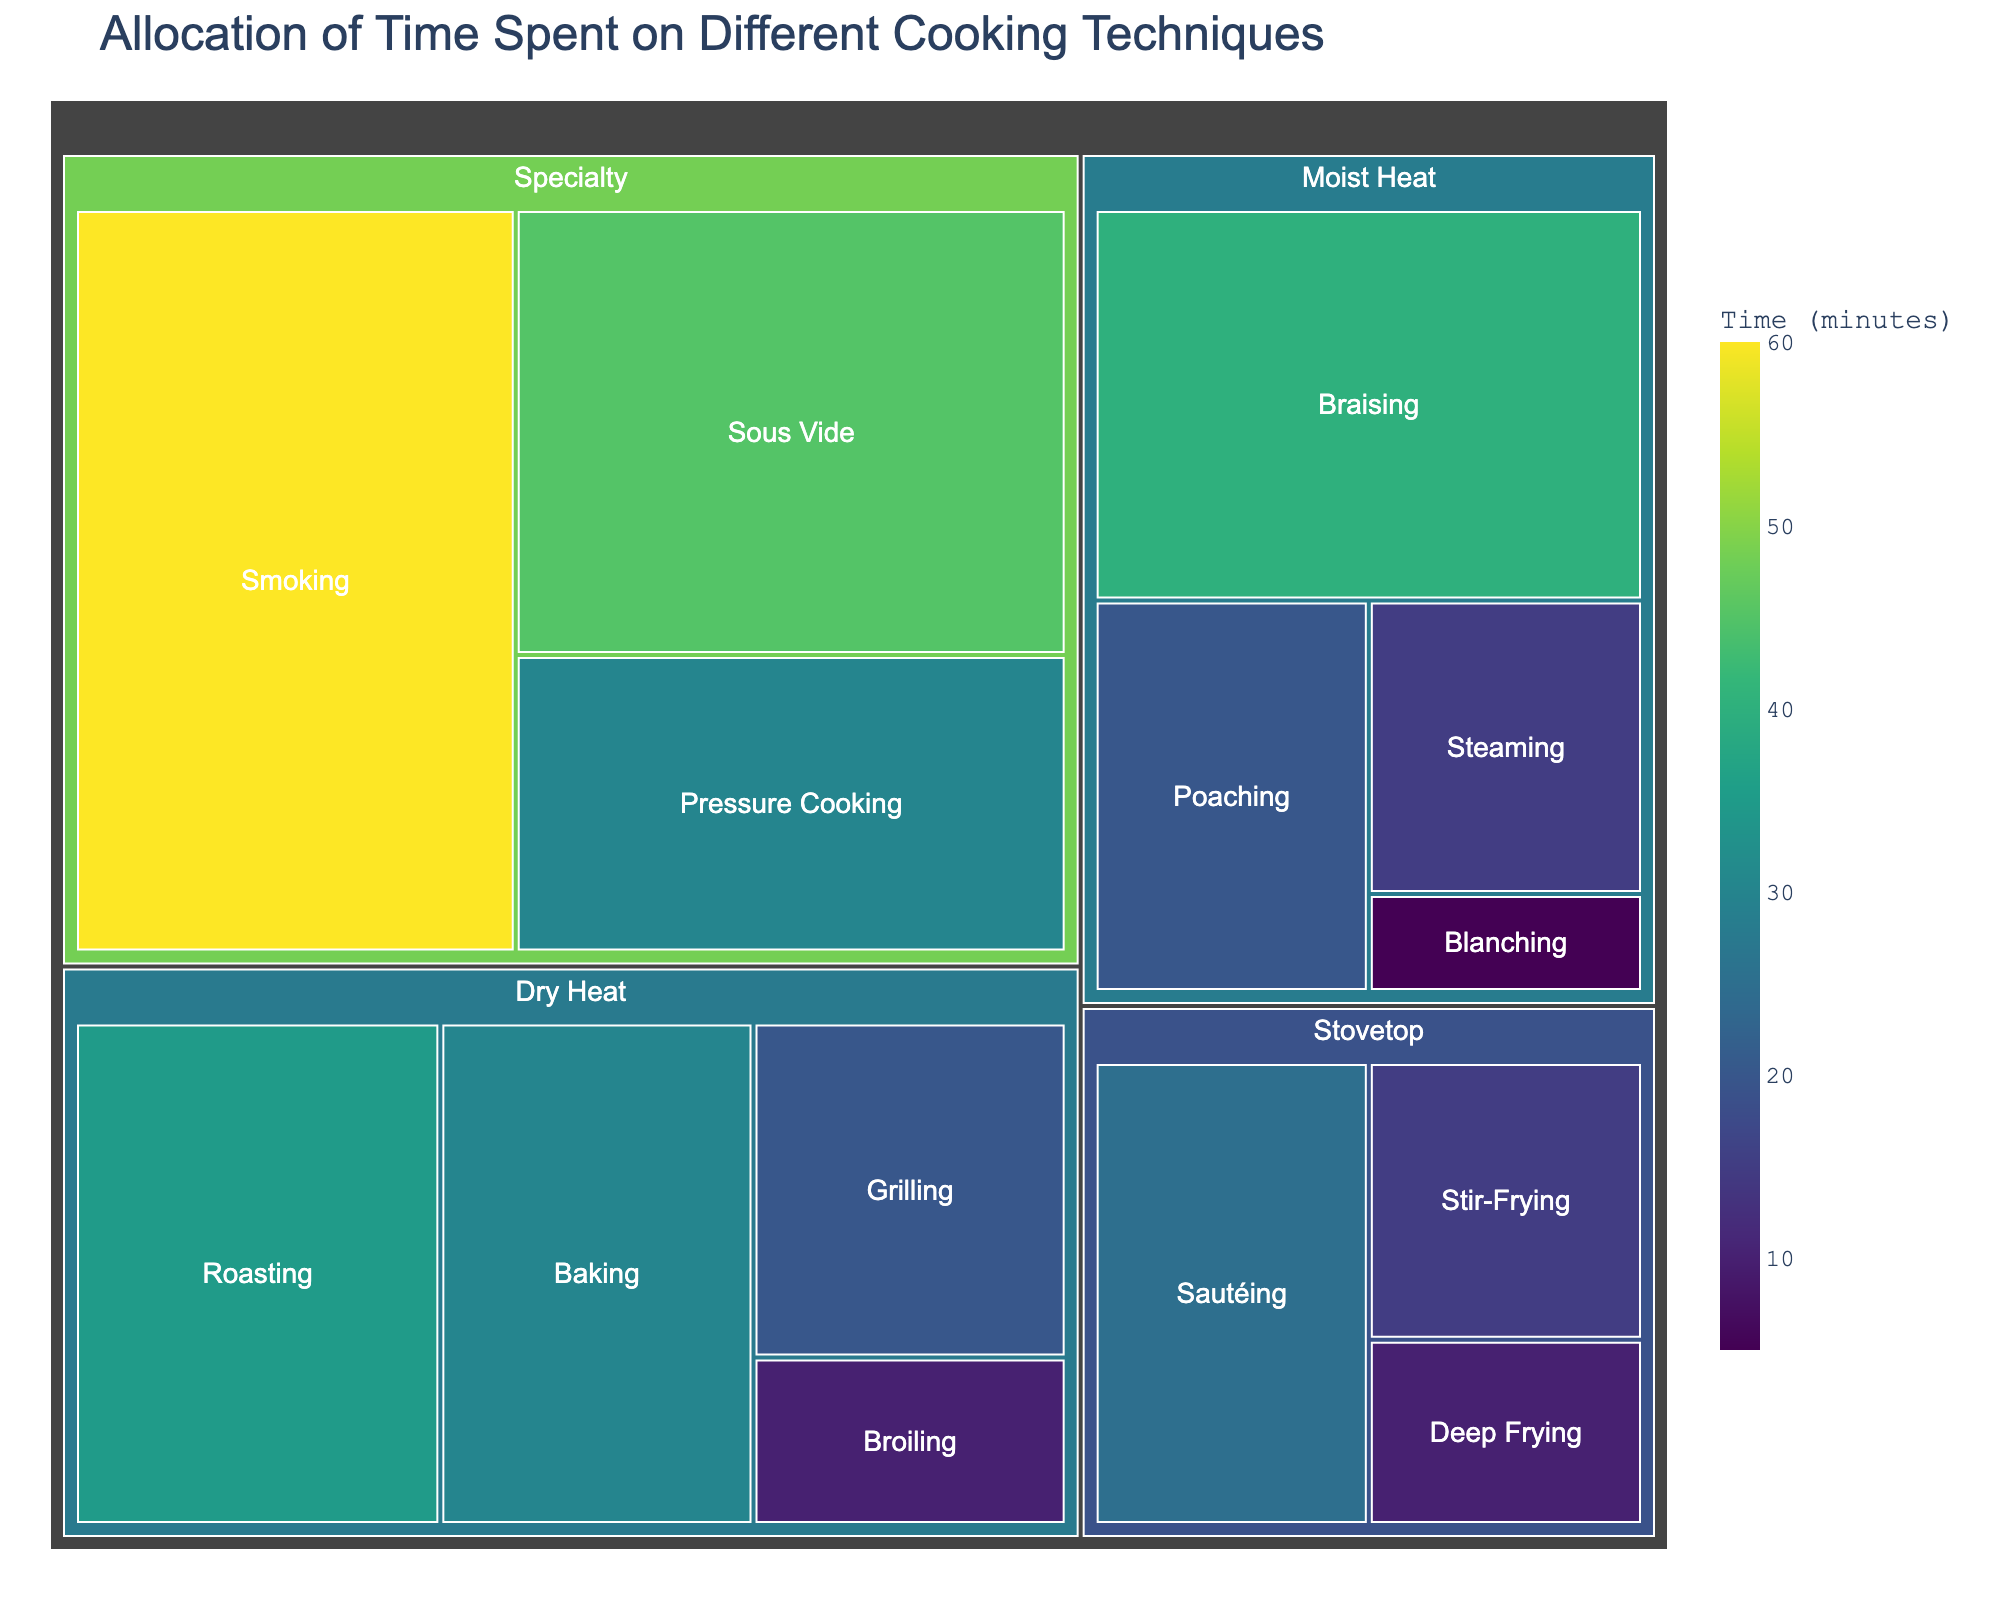What's the title of the figure? The title of the figure is typically placed prominently at the top, and it summarizes the primary topic of the data visualization. In this case, it is about the allocation of time spent on different cooking techniques in professional kitchens.
Answer: Allocation of Time Spent on Different Cooking Techniques Which cooking technique takes up the most time? In a treemap, the largest section represents the data point with the greatest value. By referring to the figure, we can find the technique with the largest area.
Answer: Smoking How much time is allocated to Stovetop techniques in total? To find the total time allocated to Stovetop techniques, we sum the times spent on each technique under the Stovetop category. From the data: Sautéing (25) + Deep Frying (10) + Stir-Frying (15) = 50 minutes.
Answer: 50 minutes Which category has the least allocated time overall? Summing the times for each category, we then compare their total times to determine the one with the minimum. Here, Stovetop (50) + Dry Heat (95) + Moist Heat (80) + Specialty (135). Stovetop has the least.
Answer: Stovetop How does the time allocated to Sous Vide compare to that allocated to Baking? Comparing the size of the sections labeled Sous Vide and Baking helps to determine which has more or less time allocated. Sous Vide (45) is larger than Baking (30).
Answer: Sous Vide has more time allocated What is the average time spent on Moist Heat techniques? Sum the time of all techniques under Moist Heat and divide by the number of techniques. (40 + 15 + 20 + 5) / 4 = 80 / 4 = 20 minutes.
Answer: 20 minutes Which specific technique in Dry Heat takes up the smallest proportion of time? Within the Dry Heat category, identify the technique with the smallest section or value. Broiling has 10 minutes, which is smaller than the time allocated to Grilling, Roasting, and Baking.
Answer: Broiling If you combined the time spent on Braising and Steaming, how would that total compare to the time spent on Smoking alone? Adding the time for Braising (40) and Steaming (15) gives us 55 minutes. Comparing this with the time for Smoking, which is 60 minutes. 55 is less than 60.
Answer: Less time than Smoking What percentage of the total time is spent on Specialty techniques? To find this, sum the time spent on Specialty techniques and divide by the total time, then multiply by 100. Total time: 50 + 95 + 80 + 135 = 360 minutes. Specialty: (45 + 30 + 60) = 135. Percentage: (135 / 360) * 100 ≈ 37.5%.
Answer: 37.5% Which technique has more time allocated: Roasting or Pressure Cooking? By comparing the time allocated to each technique within their sections, we find that Roasting (35) has more time than Pressure Cooking (30).
Answer: Roasting 